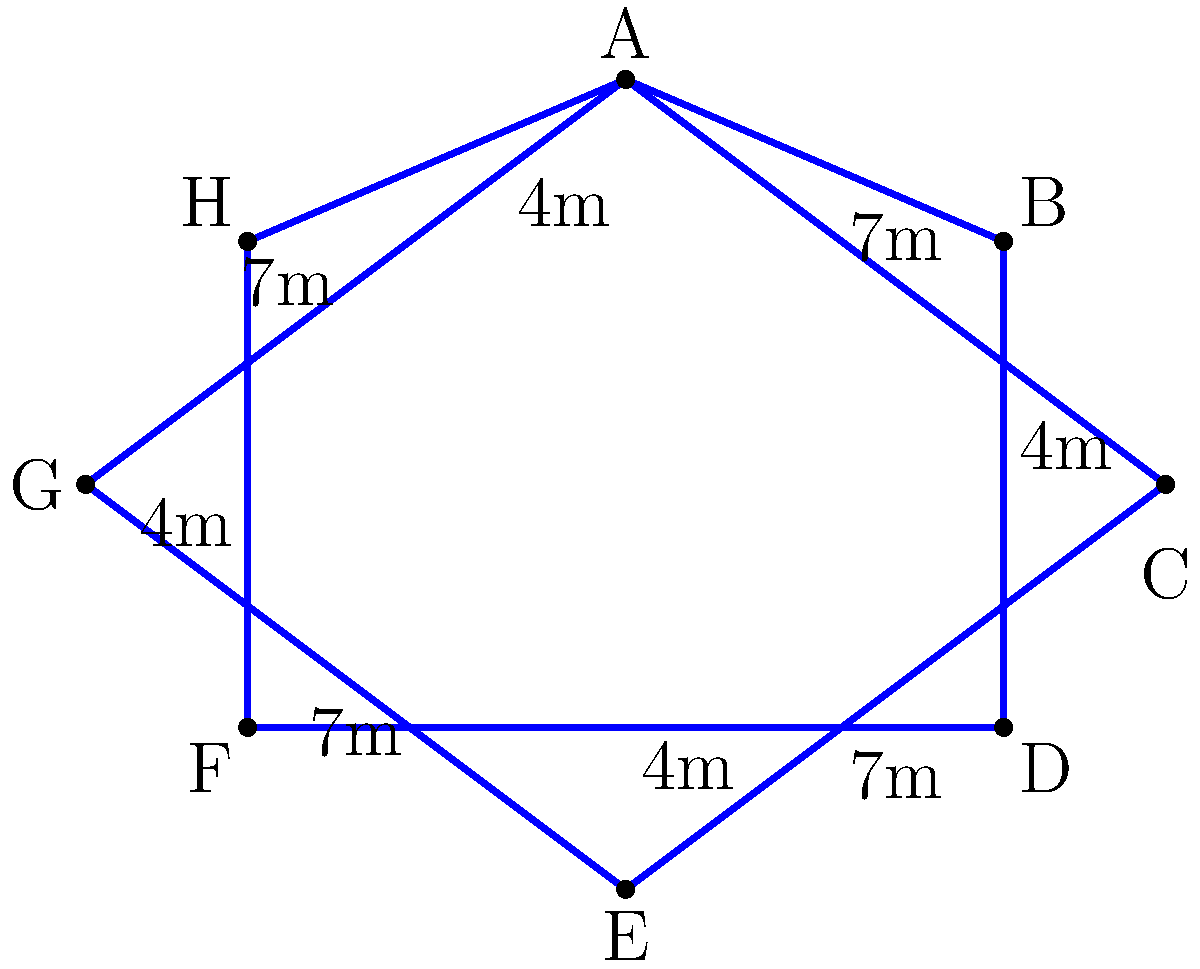At the upcoming Justin Bieber fan event, there's a special star-shaped VIP seating area. The area has 8 sides, with alternating lengths of 7 meters and 4 meters as shown in the diagram. What is the perimeter of this VIP seating area? To find the perimeter of the star-shaped VIP seating area, we need to add up the lengths of all sides. Let's break it down step by step:

1. Count the number of sides with 7 meters length:
   There are 4 sides with 7 meters each (AC, CE, EG, GA)

2. Count the number of sides with 4 meters length:
   There are 4 sides with 4 meters each (BD, DF, FH, HB)

3. Calculate the total length of 7-meter sides:
   $4 \times 7 \text{ m} = 28 \text{ m}$

4. Calculate the total length of 4-meter sides:
   $4 \times 4 \text{ m} = 16 \text{ m}$

5. Sum up the total lengths to get the perimeter:
   $\text{Perimeter} = 28 \text{ m} + 16 \text{ m} = 44 \text{ m}$

Therefore, the perimeter of the star-shaped VIP seating area is 44 meters.
Answer: 44 m 